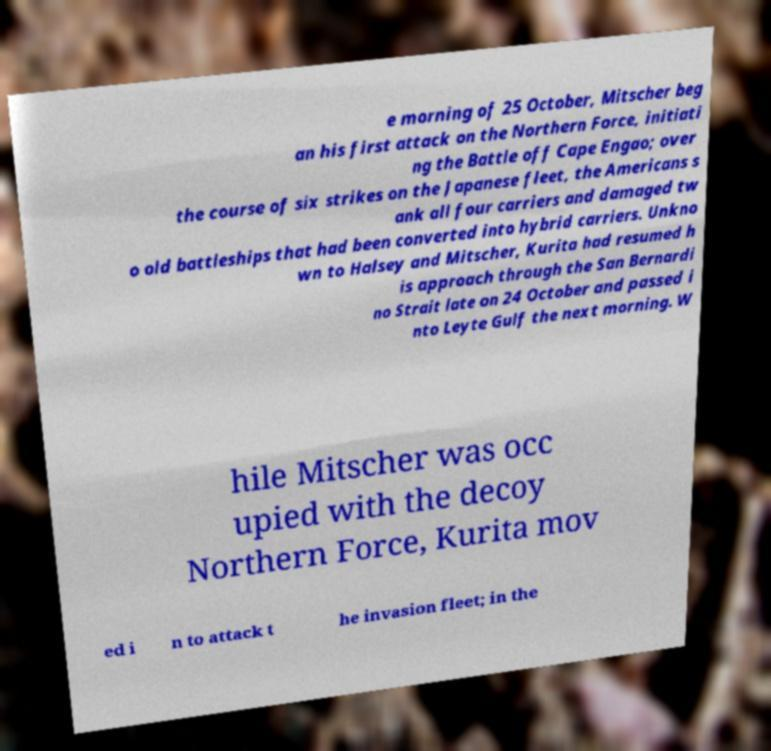I need the written content from this picture converted into text. Can you do that? e morning of 25 October, Mitscher beg an his first attack on the Northern Force, initiati ng the Battle off Cape Engao; over the course of six strikes on the Japanese fleet, the Americans s ank all four carriers and damaged tw o old battleships that had been converted into hybrid carriers. Unkno wn to Halsey and Mitscher, Kurita had resumed h is approach through the San Bernardi no Strait late on 24 October and passed i nto Leyte Gulf the next morning. W hile Mitscher was occ upied with the decoy Northern Force, Kurita mov ed i n to attack t he invasion fleet; in the 